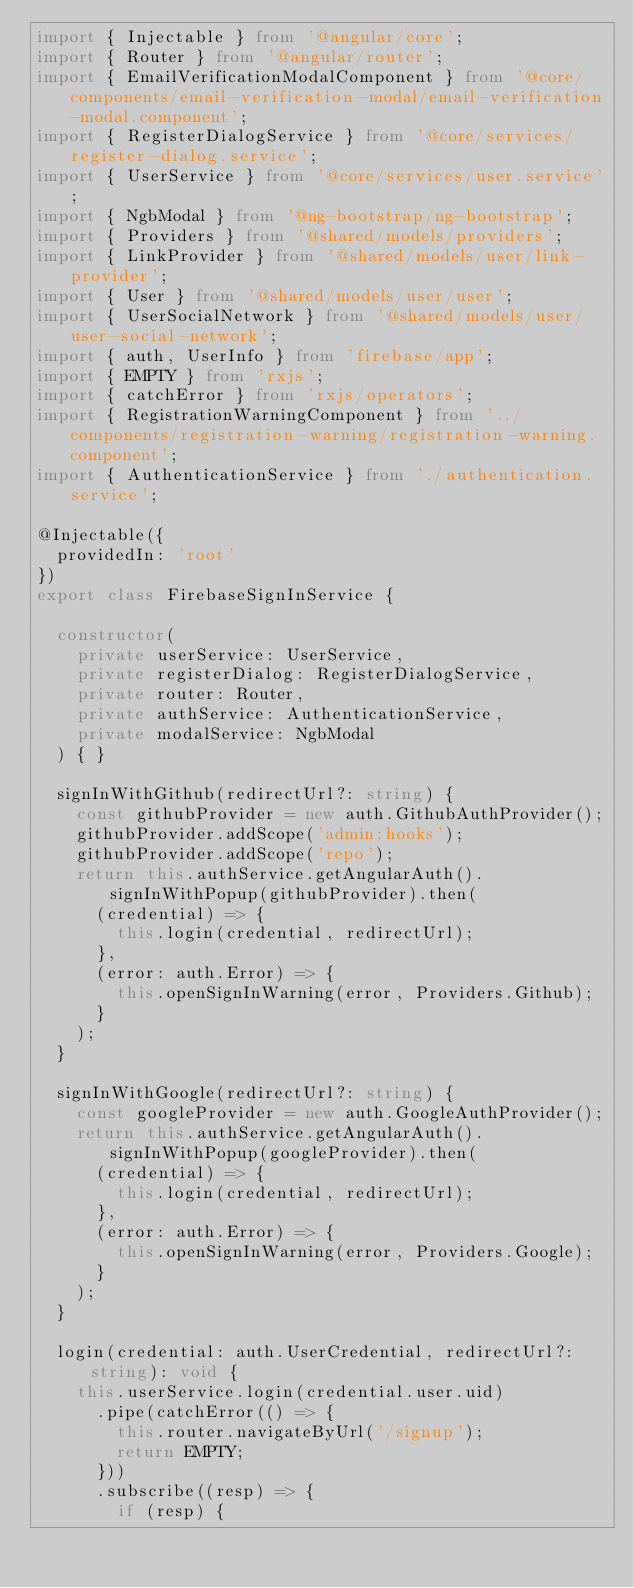Convert code to text. <code><loc_0><loc_0><loc_500><loc_500><_TypeScript_>import { Injectable } from '@angular/core';
import { Router } from '@angular/router';
import { EmailVerificationModalComponent } from '@core/components/email-verification-modal/email-verification-modal.component';
import { RegisterDialogService } from '@core/services/register-dialog.service';
import { UserService } from '@core/services/user.service';
import { NgbModal } from '@ng-bootstrap/ng-bootstrap';
import { Providers } from '@shared/models/providers';
import { LinkProvider } from '@shared/models/user/link-provider';
import { User } from '@shared/models/user/user';
import { UserSocialNetwork } from '@shared/models/user/user-social-network';
import { auth, UserInfo } from 'firebase/app';
import { EMPTY } from 'rxjs';
import { catchError } from 'rxjs/operators';
import { RegistrationWarningComponent } from '../components/registration-warning/registration-warning.component';
import { AuthenticationService } from './authentication.service';

@Injectable({
  providedIn: 'root'
})
export class FirebaseSignInService {

  constructor(
    private userService: UserService,
    private registerDialog: RegisterDialogService,
    private router: Router,
    private authService: AuthenticationService,
    private modalService: NgbModal
  ) { }

  signInWithGithub(redirectUrl?: string) {
    const githubProvider = new auth.GithubAuthProvider();
    githubProvider.addScope('admin:hooks');
    githubProvider.addScope('repo');
    return this.authService.getAngularAuth().signInWithPopup(githubProvider).then(
      (credential) => {
        this.login(credential, redirectUrl);
      },
      (error: auth.Error) => {
        this.openSignInWarning(error, Providers.Github);
      }
    );
  }

  signInWithGoogle(redirectUrl?: string) {
    const googleProvider = new auth.GoogleAuthProvider();
    return this.authService.getAngularAuth().signInWithPopup(googleProvider).then(
      (credential) => {
        this.login(credential, redirectUrl);
      },
      (error: auth.Error) => {
        this.openSignInWarning(error, Providers.Google);
      }
    );
  }

  login(credential: auth.UserCredential, redirectUrl?: string): void {
    this.userService.login(credential.user.uid)
      .pipe(catchError(() => {
        this.router.navigateByUrl('/signup');
        return EMPTY;
      }))
      .subscribe((resp) => {
        if (resp) {</code> 